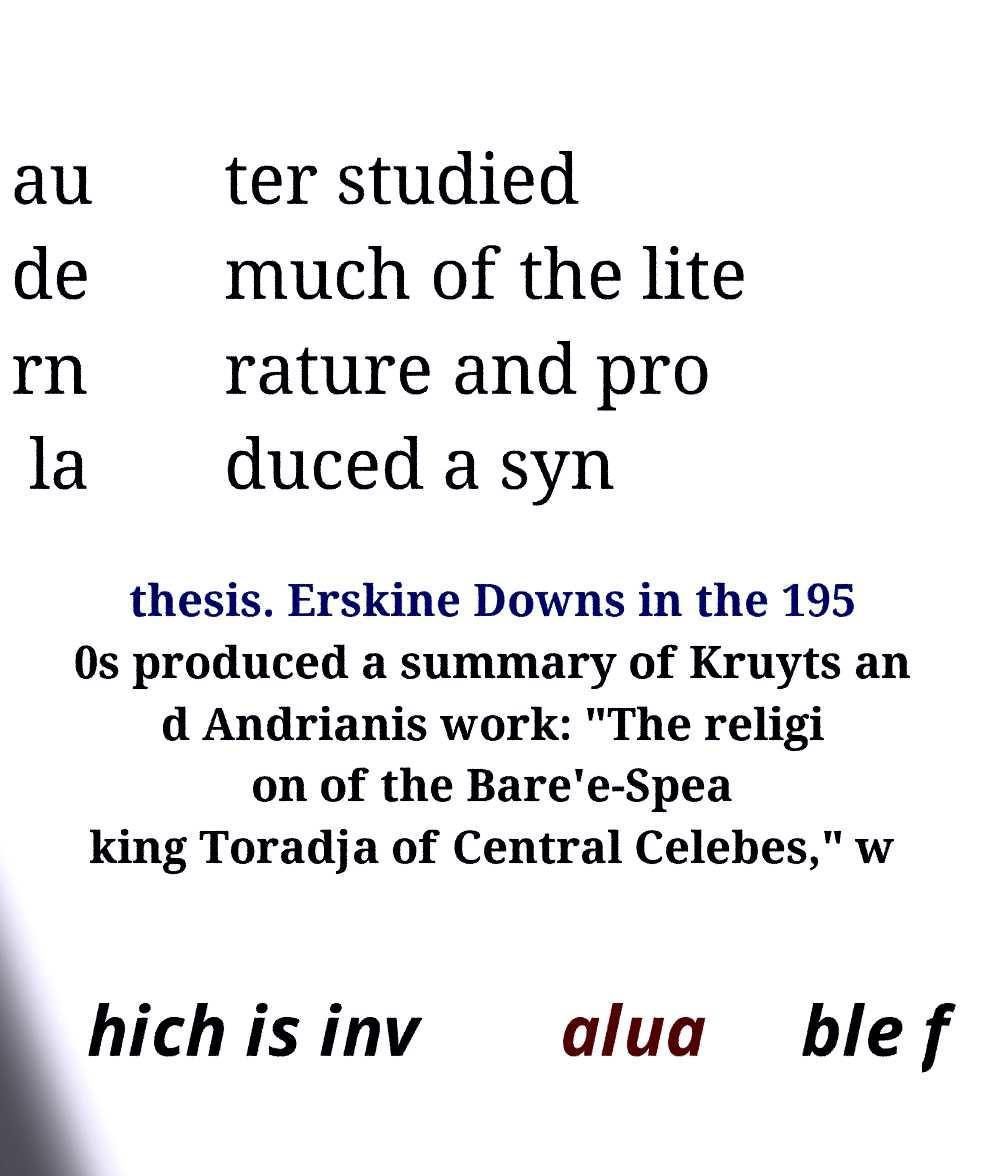For documentation purposes, I need the text within this image transcribed. Could you provide that? au de rn la ter studied much of the lite rature and pro duced a syn thesis. Erskine Downs in the 195 0s produced a summary of Kruyts an d Andrianis work: "The religi on of the Bare'e-Spea king Toradja of Central Celebes," w hich is inv alua ble f 